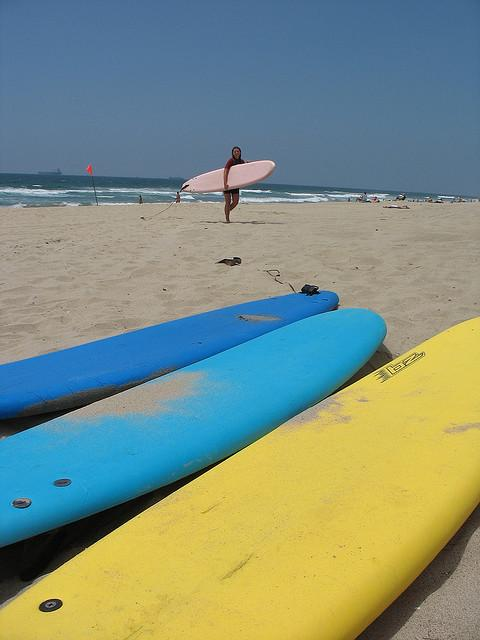Which music group would be able to use all of these boards without sharing?

Choices:
A) cream
B) nsync
C) backstreet boys
D) spice girls cream 